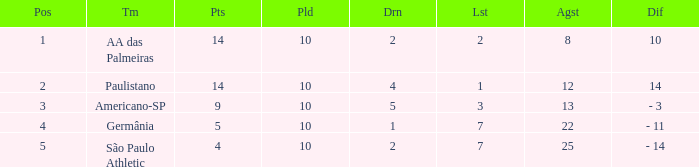What is the highest Drawn when the lost is 7 and the points are more than 4, and the against is less than 22? None. 